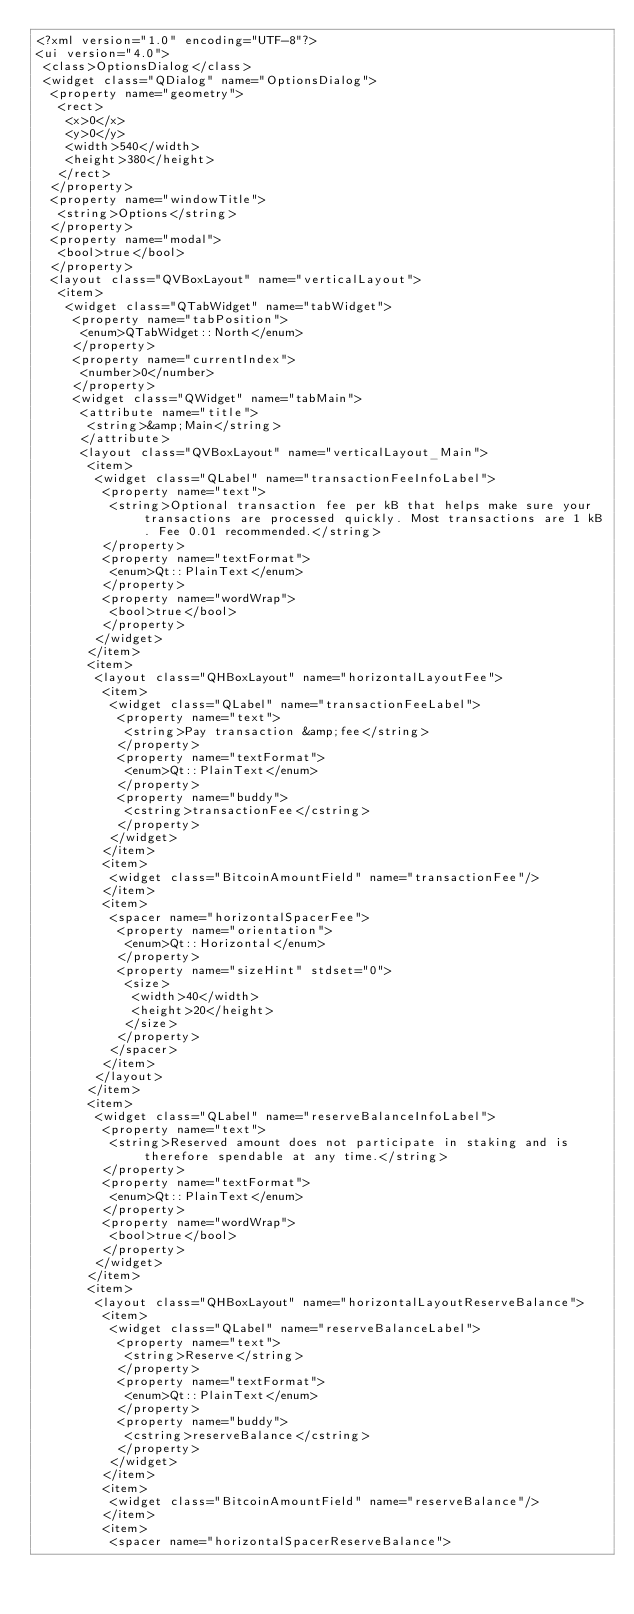Convert code to text. <code><loc_0><loc_0><loc_500><loc_500><_XML_><?xml version="1.0" encoding="UTF-8"?>
<ui version="4.0">
 <class>OptionsDialog</class>
 <widget class="QDialog" name="OptionsDialog">
  <property name="geometry">
   <rect>
    <x>0</x>
    <y>0</y>
    <width>540</width>
    <height>380</height>
   </rect>
  </property>
  <property name="windowTitle">
   <string>Options</string>
  </property>
  <property name="modal">
   <bool>true</bool>
  </property>
  <layout class="QVBoxLayout" name="verticalLayout">
   <item>
    <widget class="QTabWidget" name="tabWidget">
     <property name="tabPosition">
      <enum>QTabWidget::North</enum>
     </property>
     <property name="currentIndex">
      <number>0</number>
     </property>
     <widget class="QWidget" name="tabMain">
      <attribute name="title">
       <string>&amp;Main</string>
      </attribute>
      <layout class="QVBoxLayout" name="verticalLayout_Main">
       <item>
        <widget class="QLabel" name="transactionFeeInfoLabel">
         <property name="text">
          <string>Optional transaction fee per kB that helps make sure your transactions are processed quickly. Most transactions are 1 kB. Fee 0.01 recommended.</string>
         </property>
         <property name="textFormat">
          <enum>Qt::PlainText</enum>
         </property>
         <property name="wordWrap">
          <bool>true</bool>
         </property>
        </widget>
       </item>
       <item>
        <layout class="QHBoxLayout" name="horizontalLayoutFee">
         <item>
          <widget class="QLabel" name="transactionFeeLabel">
           <property name="text">
            <string>Pay transaction &amp;fee</string>
           </property>
           <property name="textFormat">
            <enum>Qt::PlainText</enum>
           </property>
           <property name="buddy">
            <cstring>transactionFee</cstring>
           </property>
          </widget>
         </item>
         <item>
          <widget class="BitcoinAmountField" name="transactionFee"/>
         </item>
         <item>
          <spacer name="horizontalSpacerFee">
           <property name="orientation">
            <enum>Qt::Horizontal</enum>
           </property>
           <property name="sizeHint" stdset="0">
            <size>
             <width>40</width>
             <height>20</height>
            </size>
           </property>
          </spacer>
         </item>
        </layout>
       </item>
       <item>
        <widget class="QLabel" name="reserveBalanceInfoLabel">
         <property name="text">
          <string>Reserved amount does not participate in staking and is therefore spendable at any time.</string>
         </property>
         <property name="textFormat">
          <enum>Qt::PlainText</enum>
         </property>
         <property name="wordWrap">
          <bool>true</bool>
         </property>
        </widget>
       </item>
       <item>
        <layout class="QHBoxLayout" name="horizontalLayoutReserveBalance">
         <item>
          <widget class="QLabel" name="reserveBalanceLabel">
           <property name="text">
            <string>Reserve</string>
           </property>
           <property name="textFormat">
            <enum>Qt::PlainText</enum>
           </property>
           <property name="buddy">
            <cstring>reserveBalance</cstring>
           </property>
          </widget>
         </item>
         <item>
          <widget class="BitcoinAmountField" name="reserveBalance"/>
         </item>
         <item>
          <spacer name="horizontalSpacerReserveBalance"></code> 